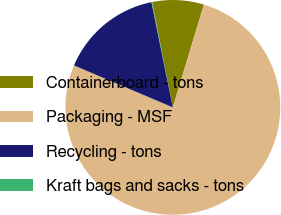<chart> <loc_0><loc_0><loc_500><loc_500><pie_chart><fcel>Containerboard - tons<fcel>Packaging - MSF<fcel>Recycling - tons<fcel>Kraft bags and sacks - tons<nl><fcel>7.76%<fcel>76.72%<fcel>15.42%<fcel>0.1%<nl></chart> 